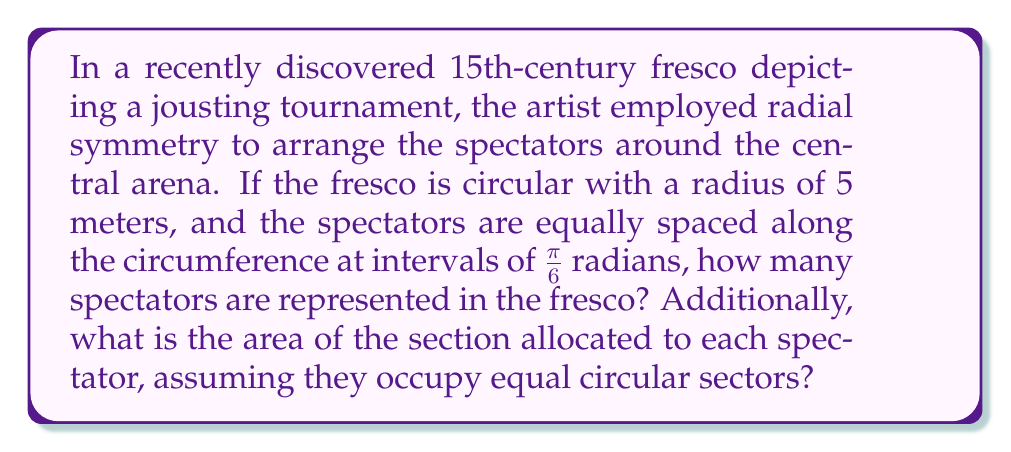Teach me how to tackle this problem. To solve this problem, we need to follow these steps:

1. Calculate the total number of spectators:
   - The fresco is circular, so the total angle is $2\pi$ radians.
   - Spectators are spaced at intervals of $\frac{\pi}{6}$ radians.
   - Number of spectators = $\frac{2\pi}{\frac{\pi}{6}} = 12$

2. Calculate the area of the entire fresco:
   - Area of a circle is given by $A = \pi r^2$
   - With a radius of 5 meters: $A = \pi (5)^2 = 25\pi$ square meters

3. Calculate the area allocated to each spectator:
   - Each spectator occupies a circular sector with central angle $\frac{\pi}{6}$
   - Area of a circular sector is given by $A_{sector} = \frac{1}{2}r^2\theta$
   - For each spectator: $A_{spectator} = \frac{1}{2}(5)^2(\frac{\pi}{6}) = \frac{25\pi}{12}$ square meters

We can verify this by multiplying the area per spectator by the number of spectators:
$\frac{25\pi}{12} \times 12 = 25\pi$, which matches the total area of the fresco.

[asy]
unitsize(30);
draw(circle((0,0),5));
for(int i=0; i<12; i++) {
  dot(5*dir(i*30));
}
draw((0,0)--(5,0));
draw(arc((0,0),1,0,30));
label("$\frac{\pi}{6}$", (0.7,0.2));
[/asy]
Answer: There are 12 spectators represented in the fresco, and each spectator is allocated an area of $\frac{25\pi}{12}$ square meters. 